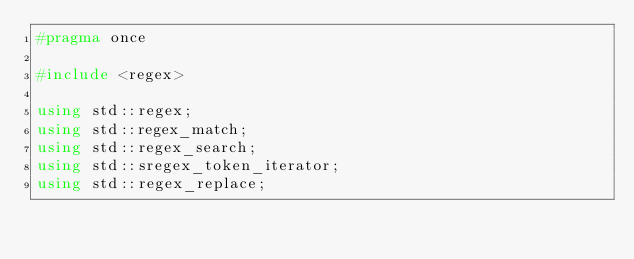<code> <loc_0><loc_0><loc_500><loc_500><_C++_>#pragma once

#include <regex>

using std::regex;
using std::regex_match;
using std::regex_search;
using std::sregex_token_iterator;
using std::regex_replace;
</code> 